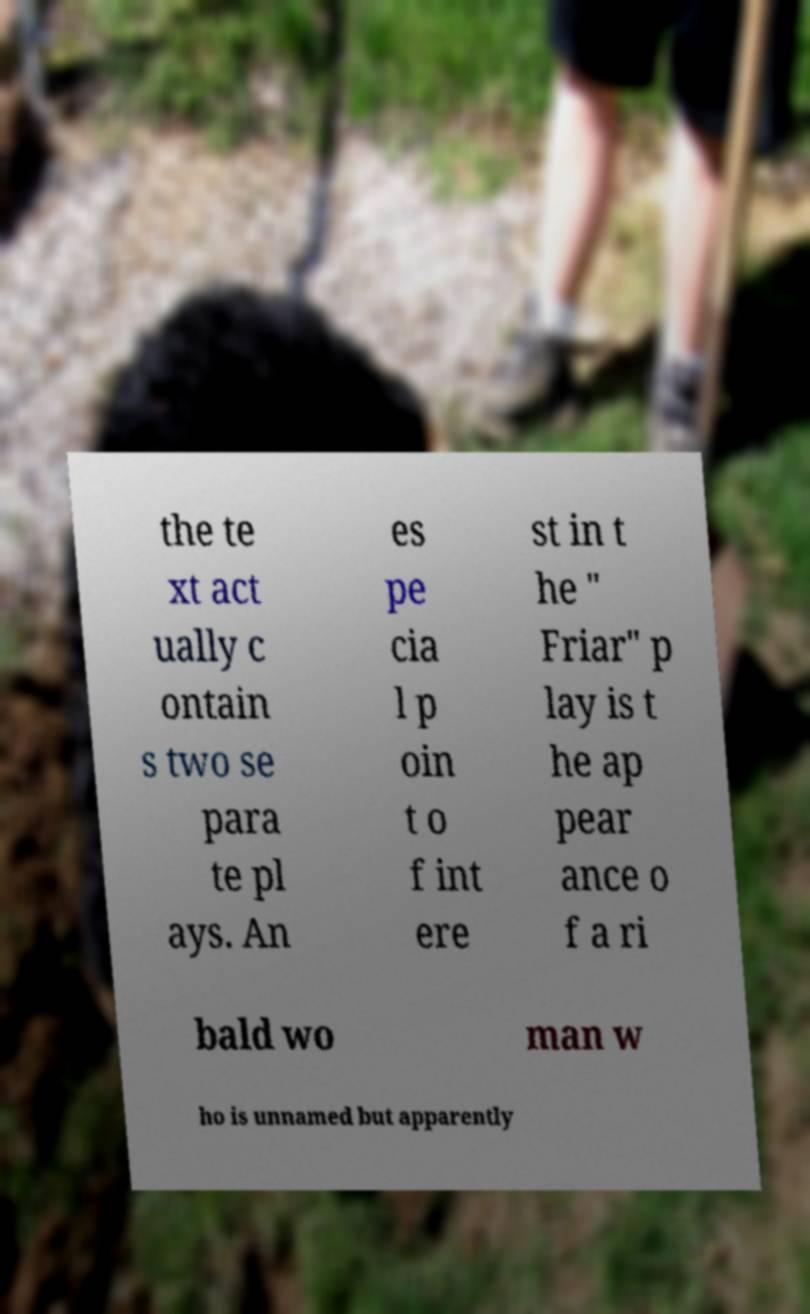Could you extract and type out the text from this image? the te xt act ually c ontain s two se para te pl ays. An es pe cia l p oin t o f int ere st in t he " Friar" p lay is t he ap pear ance o f a ri bald wo man w ho is unnamed but apparently 